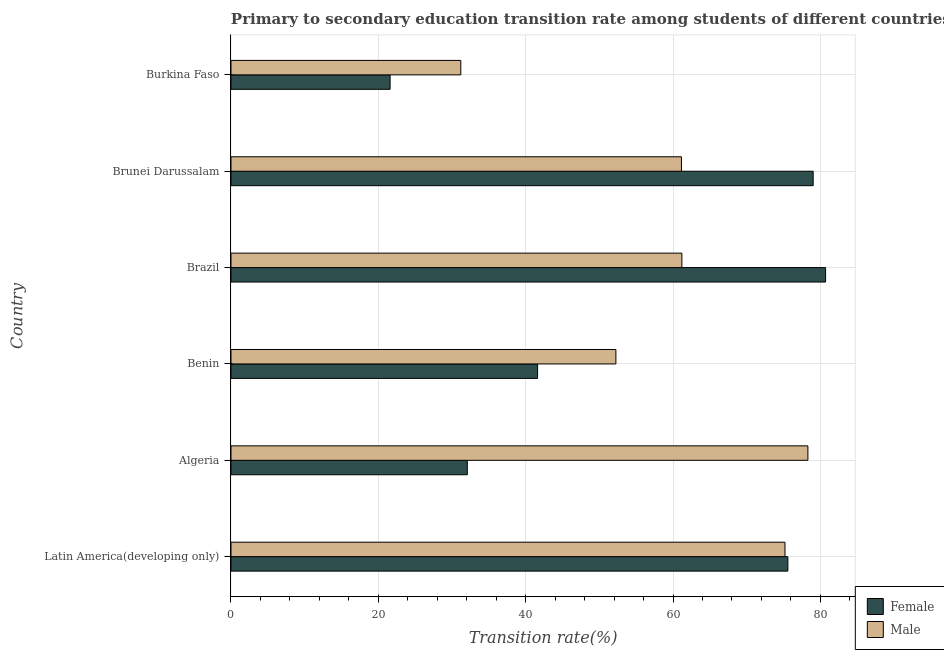How many different coloured bars are there?
Your response must be concise. 2. How many groups of bars are there?
Make the answer very short. 6. Are the number of bars on each tick of the Y-axis equal?
Provide a short and direct response. Yes. What is the label of the 5th group of bars from the top?
Your response must be concise. Algeria. In how many cases, is the number of bars for a given country not equal to the number of legend labels?
Give a very brief answer. 0. What is the transition rate among male students in Brazil?
Ensure brevity in your answer.  61.2. Across all countries, what is the maximum transition rate among female students?
Your answer should be compact. 80.71. Across all countries, what is the minimum transition rate among female students?
Ensure brevity in your answer.  21.6. In which country was the transition rate among female students minimum?
Keep it short and to the point. Burkina Faso. What is the total transition rate among female students in the graph?
Your response must be concise. 330.61. What is the difference between the transition rate among male students in Algeria and that in Latin America(developing only)?
Offer a very short reply. 3.11. What is the difference between the transition rate among male students in Algeria and the transition rate among female students in Brunei Darussalam?
Make the answer very short. -0.72. What is the average transition rate among male students per country?
Offer a very short reply. 59.88. What is the difference between the transition rate among male students and transition rate among female students in Benin?
Keep it short and to the point. 10.63. What is the ratio of the transition rate among male students in Algeria to that in Brazil?
Your answer should be very brief. 1.28. Is the transition rate among male students in Algeria less than that in Brazil?
Offer a terse response. No. What is the difference between the highest and the second highest transition rate among female students?
Provide a short and direct response. 1.68. What is the difference between the highest and the lowest transition rate among male students?
Make the answer very short. 47.11. In how many countries, is the transition rate among female students greater than the average transition rate among female students taken over all countries?
Your response must be concise. 3. What does the 1st bar from the top in Brazil represents?
Offer a very short reply. Male. What does the 2nd bar from the bottom in Burkina Faso represents?
Offer a terse response. Male. Are all the bars in the graph horizontal?
Your answer should be compact. Yes. What is the difference between two consecutive major ticks on the X-axis?
Your answer should be compact. 20. Are the values on the major ticks of X-axis written in scientific E-notation?
Offer a terse response. No. Does the graph contain any zero values?
Provide a short and direct response. No. How are the legend labels stacked?
Your response must be concise. Vertical. What is the title of the graph?
Your answer should be very brief. Primary to secondary education transition rate among students of different countries. What is the label or title of the X-axis?
Provide a short and direct response. Transition rate(%). What is the label or title of the Y-axis?
Provide a short and direct response. Country. What is the Transition rate(%) of Female in Latin America(developing only)?
Your response must be concise. 75.59. What is the Transition rate(%) in Male in Latin America(developing only)?
Your answer should be very brief. 75.2. What is the Transition rate(%) of Female in Algeria?
Your response must be concise. 32.08. What is the Transition rate(%) of Male in Algeria?
Your response must be concise. 78.31. What is the Transition rate(%) in Female in Benin?
Your response must be concise. 41.62. What is the Transition rate(%) in Male in Benin?
Your response must be concise. 52.25. What is the Transition rate(%) in Female in Brazil?
Make the answer very short. 80.71. What is the Transition rate(%) in Male in Brazil?
Provide a short and direct response. 61.2. What is the Transition rate(%) of Female in Brunei Darussalam?
Your answer should be compact. 79.02. What is the Transition rate(%) of Male in Brunei Darussalam?
Provide a short and direct response. 61.14. What is the Transition rate(%) of Female in Burkina Faso?
Your answer should be very brief. 21.6. What is the Transition rate(%) of Male in Burkina Faso?
Provide a short and direct response. 31.19. Across all countries, what is the maximum Transition rate(%) in Female?
Make the answer very short. 80.71. Across all countries, what is the maximum Transition rate(%) in Male?
Keep it short and to the point. 78.31. Across all countries, what is the minimum Transition rate(%) in Female?
Your answer should be compact. 21.6. Across all countries, what is the minimum Transition rate(%) of Male?
Ensure brevity in your answer.  31.19. What is the total Transition rate(%) in Female in the graph?
Give a very brief answer. 330.61. What is the total Transition rate(%) of Male in the graph?
Provide a succinct answer. 359.29. What is the difference between the Transition rate(%) in Female in Latin America(developing only) and that in Algeria?
Offer a terse response. 43.51. What is the difference between the Transition rate(%) in Male in Latin America(developing only) and that in Algeria?
Your answer should be very brief. -3.11. What is the difference between the Transition rate(%) in Female in Latin America(developing only) and that in Benin?
Offer a very short reply. 33.97. What is the difference between the Transition rate(%) in Male in Latin America(developing only) and that in Benin?
Make the answer very short. 22.95. What is the difference between the Transition rate(%) in Female in Latin America(developing only) and that in Brazil?
Offer a very short reply. -5.12. What is the difference between the Transition rate(%) of Male in Latin America(developing only) and that in Brazil?
Your answer should be very brief. 14. What is the difference between the Transition rate(%) of Female in Latin America(developing only) and that in Brunei Darussalam?
Give a very brief answer. -3.44. What is the difference between the Transition rate(%) in Male in Latin America(developing only) and that in Brunei Darussalam?
Your response must be concise. 14.05. What is the difference between the Transition rate(%) of Female in Latin America(developing only) and that in Burkina Faso?
Provide a succinct answer. 53.99. What is the difference between the Transition rate(%) of Male in Latin America(developing only) and that in Burkina Faso?
Offer a terse response. 44. What is the difference between the Transition rate(%) of Female in Algeria and that in Benin?
Make the answer very short. -9.54. What is the difference between the Transition rate(%) in Male in Algeria and that in Benin?
Provide a short and direct response. 26.06. What is the difference between the Transition rate(%) in Female in Algeria and that in Brazil?
Give a very brief answer. -48.63. What is the difference between the Transition rate(%) in Male in Algeria and that in Brazil?
Provide a short and direct response. 17.11. What is the difference between the Transition rate(%) of Female in Algeria and that in Brunei Darussalam?
Your answer should be very brief. -46.95. What is the difference between the Transition rate(%) of Male in Algeria and that in Brunei Darussalam?
Provide a short and direct response. 17.16. What is the difference between the Transition rate(%) in Female in Algeria and that in Burkina Faso?
Offer a very short reply. 10.48. What is the difference between the Transition rate(%) in Male in Algeria and that in Burkina Faso?
Offer a terse response. 47.11. What is the difference between the Transition rate(%) of Female in Benin and that in Brazil?
Your answer should be compact. -39.09. What is the difference between the Transition rate(%) of Male in Benin and that in Brazil?
Your answer should be very brief. -8.96. What is the difference between the Transition rate(%) in Female in Benin and that in Brunei Darussalam?
Your answer should be very brief. -37.41. What is the difference between the Transition rate(%) of Male in Benin and that in Brunei Darussalam?
Your answer should be compact. -8.9. What is the difference between the Transition rate(%) in Female in Benin and that in Burkina Faso?
Give a very brief answer. 20.02. What is the difference between the Transition rate(%) in Male in Benin and that in Burkina Faso?
Ensure brevity in your answer.  21.05. What is the difference between the Transition rate(%) in Female in Brazil and that in Brunei Darussalam?
Give a very brief answer. 1.68. What is the difference between the Transition rate(%) of Male in Brazil and that in Brunei Darussalam?
Provide a succinct answer. 0.06. What is the difference between the Transition rate(%) of Female in Brazil and that in Burkina Faso?
Provide a short and direct response. 59.11. What is the difference between the Transition rate(%) in Male in Brazil and that in Burkina Faso?
Your answer should be very brief. 30.01. What is the difference between the Transition rate(%) of Female in Brunei Darussalam and that in Burkina Faso?
Make the answer very short. 57.42. What is the difference between the Transition rate(%) in Male in Brunei Darussalam and that in Burkina Faso?
Your response must be concise. 29.95. What is the difference between the Transition rate(%) in Female in Latin America(developing only) and the Transition rate(%) in Male in Algeria?
Give a very brief answer. -2.72. What is the difference between the Transition rate(%) of Female in Latin America(developing only) and the Transition rate(%) of Male in Benin?
Your answer should be very brief. 23.34. What is the difference between the Transition rate(%) in Female in Latin America(developing only) and the Transition rate(%) in Male in Brazil?
Your answer should be very brief. 14.39. What is the difference between the Transition rate(%) of Female in Latin America(developing only) and the Transition rate(%) of Male in Brunei Darussalam?
Ensure brevity in your answer.  14.44. What is the difference between the Transition rate(%) in Female in Latin America(developing only) and the Transition rate(%) in Male in Burkina Faso?
Ensure brevity in your answer.  44.39. What is the difference between the Transition rate(%) of Female in Algeria and the Transition rate(%) of Male in Benin?
Provide a succinct answer. -20.17. What is the difference between the Transition rate(%) of Female in Algeria and the Transition rate(%) of Male in Brazil?
Give a very brief answer. -29.12. What is the difference between the Transition rate(%) in Female in Algeria and the Transition rate(%) in Male in Brunei Darussalam?
Give a very brief answer. -29.07. What is the difference between the Transition rate(%) of Female in Algeria and the Transition rate(%) of Male in Burkina Faso?
Your answer should be very brief. 0.88. What is the difference between the Transition rate(%) of Female in Benin and the Transition rate(%) of Male in Brazil?
Your answer should be compact. -19.59. What is the difference between the Transition rate(%) in Female in Benin and the Transition rate(%) in Male in Brunei Darussalam?
Your answer should be compact. -19.53. What is the difference between the Transition rate(%) of Female in Benin and the Transition rate(%) of Male in Burkina Faso?
Provide a succinct answer. 10.42. What is the difference between the Transition rate(%) of Female in Brazil and the Transition rate(%) of Male in Brunei Darussalam?
Your answer should be compact. 19.56. What is the difference between the Transition rate(%) in Female in Brazil and the Transition rate(%) in Male in Burkina Faso?
Give a very brief answer. 49.51. What is the difference between the Transition rate(%) of Female in Brunei Darussalam and the Transition rate(%) of Male in Burkina Faso?
Offer a terse response. 47.83. What is the average Transition rate(%) of Female per country?
Your response must be concise. 55.1. What is the average Transition rate(%) in Male per country?
Give a very brief answer. 59.88. What is the difference between the Transition rate(%) in Female and Transition rate(%) in Male in Latin America(developing only)?
Make the answer very short. 0.39. What is the difference between the Transition rate(%) of Female and Transition rate(%) of Male in Algeria?
Make the answer very short. -46.23. What is the difference between the Transition rate(%) of Female and Transition rate(%) of Male in Benin?
Ensure brevity in your answer.  -10.63. What is the difference between the Transition rate(%) in Female and Transition rate(%) in Male in Brazil?
Ensure brevity in your answer.  19.51. What is the difference between the Transition rate(%) of Female and Transition rate(%) of Male in Brunei Darussalam?
Provide a succinct answer. 17.88. What is the difference between the Transition rate(%) in Female and Transition rate(%) in Male in Burkina Faso?
Your answer should be compact. -9.59. What is the ratio of the Transition rate(%) of Female in Latin America(developing only) to that in Algeria?
Ensure brevity in your answer.  2.36. What is the ratio of the Transition rate(%) of Male in Latin America(developing only) to that in Algeria?
Keep it short and to the point. 0.96. What is the ratio of the Transition rate(%) in Female in Latin America(developing only) to that in Benin?
Offer a terse response. 1.82. What is the ratio of the Transition rate(%) in Male in Latin America(developing only) to that in Benin?
Your response must be concise. 1.44. What is the ratio of the Transition rate(%) of Female in Latin America(developing only) to that in Brazil?
Offer a very short reply. 0.94. What is the ratio of the Transition rate(%) of Male in Latin America(developing only) to that in Brazil?
Provide a succinct answer. 1.23. What is the ratio of the Transition rate(%) of Female in Latin America(developing only) to that in Brunei Darussalam?
Provide a short and direct response. 0.96. What is the ratio of the Transition rate(%) of Male in Latin America(developing only) to that in Brunei Darussalam?
Provide a succinct answer. 1.23. What is the ratio of the Transition rate(%) of Female in Latin America(developing only) to that in Burkina Faso?
Provide a short and direct response. 3.5. What is the ratio of the Transition rate(%) of Male in Latin America(developing only) to that in Burkina Faso?
Your answer should be compact. 2.41. What is the ratio of the Transition rate(%) in Female in Algeria to that in Benin?
Ensure brevity in your answer.  0.77. What is the ratio of the Transition rate(%) of Male in Algeria to that in Benin?
Your response must be concise. 1.5. What is the ratio of the Transition rate(%) in Female in Algeria to that in Brazil?
Make the answer very short. 0.4. What is the ratio of the Transition rate(%) in Male in Algeria to that in Brazil?
Your answer should be compact. 1.28. What is the ratio of the Transition rate(%) of Female in Algeria to that in Brunei Darussalam?
Make the answer very short. 0.41. What is the ratio of the Transition rate(%) of Male in Algeria to that in Brunei Darussalam?
Your answer should be very brief. 1.28. What is the ratio of the Transition rate(%) of Female in Algeria to that in Burkina Faso?
Provide a short and direct response. 1.49. What is the ratio of the Transition rate(%) in Male in Algeria to that in Burkina Faso?
Offer a very short reply. 2.51. What is the ratio of the Transition rate(%) in Female in Benin to that in Brazil?
Ensure brevity in your answer.  0.52. What is the ratio of the Transition rate(%) in Male in Benin to that in Brazil?
Make the answer very short. 0.85. What is the ratio of the Transition rate(%) of Female in Benin to that in Brunei Darussalam?
Ensure brevity in your answer.  0.53. What is the ratio of the Transition rate(%) of Male in Benin to that in Brunei Darussalam?
Provide a short and direct response. 0.85. What is the ratio of the Transition rate(%) in Female in Benin to that in Burkina Faso?
Offer a terse response. 1.93. What is the ratio of the Transition rate(%) in Male in Benin to that in Burkina Faso?
Offer a terse response. 1.67. What is the ratio of the Transition rate(%) of Female in Brazil to that in Brunei Darussalam?
Offer a very short reply. 1.02. What is the ratio of the Transition rate(%) in Male in Brazil to that in Brunei Darussalam?
Make the answer very short. 1. What is the ratio of the Transition rate(%) of Female in Brazil to that in Burkina Faso?
Provide a succinct answer. 3.74. What is the ratio of the Transition rate(%) in Male in Brazil to that in Burkina Faso?
Your answer should be very brief. 1.96. What is the ratio of the Transition rate(%) of Female in Brunei Darussalam to that in Burkina Faso?
Give a very brief answer. 3.66. What is the ratio of the Transition rate(%) in Male in Brunei Darussalam to that in Burkina Faso?
Give a very brief answer. 1.96. What is the difference between the highest and the second highest Transition rate(%) in Female?
Your answer should be compact. 1.68. What is the difference between the highest and the second highest Transition rate(%) in Male?
Give a very brief answer. 3.11. What is the difference between the highest and the lowest Transition rate(%) in Female?
Offer a terse response. 59.11. What is the difference between the highest and the lowest Transition rate(%) of Male?
Give a very brief answer. 47.11. 